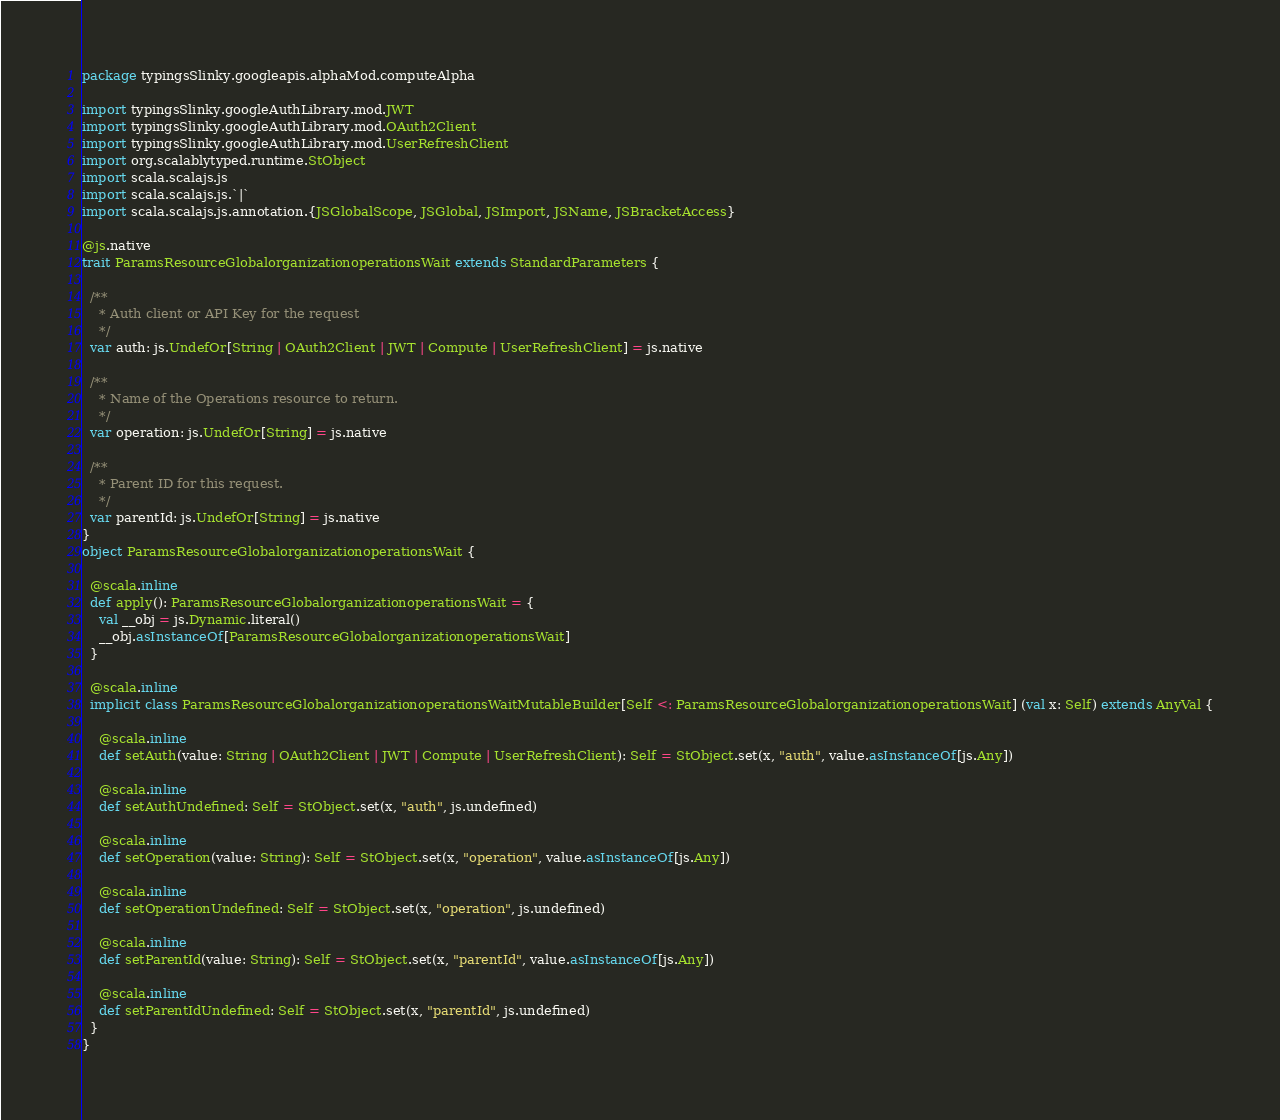Convert code to text. <code><loc_0><loc_0><loc_500><loc_500><_Scala_>package typingsSlinky.googleapis.alphaMod.computeAlpha

import typingsSlinky.googleAuthLibrary.mod.JWT
import typingsSlinky.googleAuthLibrary.mod.OAuth2Client
import typingsSlinky.googleAuthLibrary.mod.UserRefreshClient
import org.scalablytyped.runtime.StObject
import scala.scalajs.js
import scala.scalajs.js.`|`
import scala.scalajs.js.annotation.{JSGlobalScope, JSGlobal, JSImport, JSName, JSBracketAccess}

@js.native
trait ParamsResourceGlobalorganizationoperationsWait extends StandardParameters {
  
  /**
    * Auth client or API Key for the request
    */
  var auth: js.UndefOr[String | OAuth2Client | JWT | Compute | UserRefreshClient] = js.native
  
  /**
    * Name of the Operations resource to return.
    */
  var operation: js.UndefOr[String] = js.native
  
  /**
    * Parent ID for this request.
    */
  var parentId: js.UndefOr[String] = js.native
}
object ParamsResourceGlobalorganizationoperationsWait {
  
  @scala.inline
  def apply(): ParamsResourceGlobalorganizationoperationsWait = {
    val __obj = js.Dynamic.literal()
    __obj.asInstanceOf[ParamsResourceGlobalorganizationoperationsWait]
  }
  
  @scala.inline
  implicit class ParamsResourceGlobalorganizationoperationsWaitMutableBuilder[Self <: ParamsResourceGlobalorganizationoperationsWait] (val x: Self) extends AnyVal {
    
    @scala.inline
    def setAuth(value: String | OAuth2Client | JWT | Compute | UserRefreshClient): Self = StObject.set(x, "auth", value.asInstanceOf[js.Any])
    
    @scala.inline
    def setAuthUndefined: Self = StObject.set(x, "auth", js.undefined)
    
    @scala.inline
    def setOperation(value: String): Self = StObject.set(x, "operation", value.asInstanceOf[js.Any])
    
    @scala.inline
    def setOperationUndefined: Self = StObject.set(x, "operation", js.undefined)
    
    @scala.inline
    def setParentId(value: String): Self = StObject.set(x, "parentId", value.asInstanceOf[js.Any])
    
    @scala.inline
    def setParentIdUndefined: Self = StObject.set(x, "parentId", js.undefined)
  }
}
</code> 